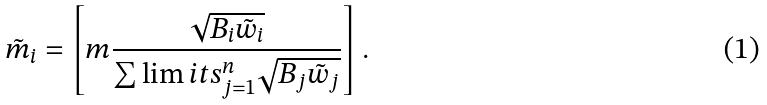Convert formula to latex. <formula><loc_0><loc_0><loc_500><loc_500>\tilde { m } _ { i } = \left [ m \frac { \sqrt { B _ { i } \tilde { w } _ { i } } } { \sum \lim i t s _ { j = 1 } ^ { n } \sqrt { B _ { j } \tilde { w } _ { j } } } \right ] .</formula> 